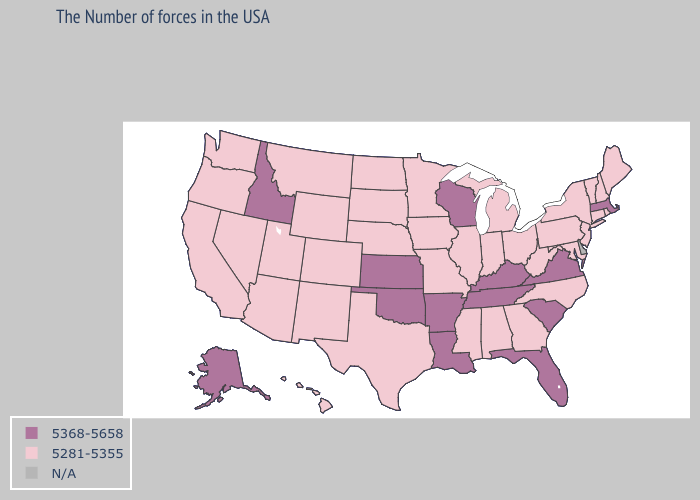Name the states that have a value in the range 5368-5658?
Keep it brief. Massachusetts, Virginia, South Carolina, Florida, Kentucky, Tennessee, Wisconsin, Louisiana, Arkansas, Kansas, Oklahoma, Idaho, Alaska. Name the states that have a value in the range N/A?
Keep it brief. Delaware. What is the highest value in states that border North Dakota?
Short answer required. 5281-5355. Name the states that have a value in the range 5281-5355?
Answer briefly. Maine, Rhode Island, New Hampshire, Vermont, Connecticut, New York, New Jersey, Maryland, Pennsylvania, North Carolina, West Virginia, Ohio, Georgia, Michigan, Indiana, Alabama, Illinois, Mississippi, Missouri, Minnesota, Iowa, Nebraska, Texas, South Dakota, North Dakota, Wyoming, Colorado, New Mexico, Utah, Montana, Arizona, Nevada, California, Washington, Oregon, Hawaii. Name the states that have a value in the range 5281-5355?
Short answer required. Maine, Rhode Island, New Hampshire, Vermont, Connecticut, New York, New Jersey, Maryland, Pennsylvania, North Carolina, West Virginia, Ohio, Georgia, Michigan, Indiana, Alabama, Illinois, Mississippi, Missouri, Minnesota, Iowa, Nebraska, Texas, South Dakota, North Dakota, Wyoming, Colorado, New Mexico, Utah, Montana, Arizona, Nevada, California, Washington, Oregon, Hawaii. Which states hav the highest value in the Northeast?
Keep it brief. Massachusetts. Does Kansas have the highest value in the USA?
Quick response, please. Yes. Name the states that have a value in the range 5281-5355?
Answer briefly. Maine, Rhode Island, New Hampshire, Vermont, Connecticut, New York, New Jersey, Maryland, Pennsylvania, North Carolina, West Virginia, Ohio, Georgia, Michigan, Indiana, Alabama, Illinois, Mississippi, Missouri, Minnesota, Iowa, Nebraska, Texas, South Dakota, North Dakota, Wyoming, Colorado, New Mexico, Utah, Montana, Arizona, Nevada, California, Washington, Oregon, Hawaii. Name the states that have a value in the range 5368-5658?
Write a very short answer. Massachusetts, Virginia, South Carolina, Florida, Kentucky, Tennessee, Wisconsin, Louisiana, Arkansas, Kansas, Oklahoma, Idaho, Alaska. Does the map have missing data?
Concise answer only. Yes. Name the states that have a value in the range 5281-5355?
Be succinct. Maine, Rhode Island, New Hampshire, Vermont, Connecticut, New York, New Jersey, Maryland, Pennsylvania, North Carolina, West Virginia, Ohio, Georgia, Michigan, Indiana, Alabama, Illinois, Mississippi, Missouri, Minnesota, Iowa, Nebraska, Texas, South Dakota, North Dakota, Wyoming, Colorado, New Mexico, Utah, Montana, Arizona, Nevada, California, Washington, Oregon, Hawaii. What is the value of Virginia?
Keep it brief. 5368-5658. Does the map have missing data?
Short answer required. Yes. What is the highest value in states that border Florida?
Short answer required. 5281-5355. 